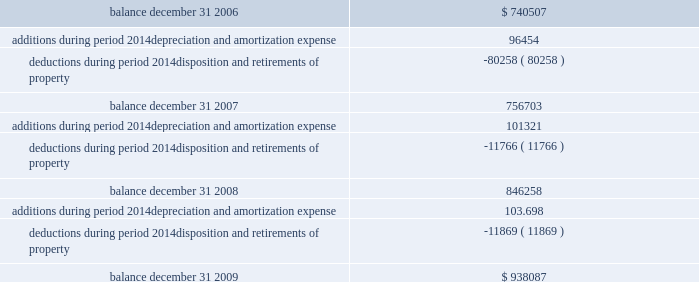Federal realty investment trust schedule iii summary of real estate and accumulated depreciation 2014continued three years ended december 31 , 2009 reconciliation of accumulated depreciation and amortization ( in thousands ) .

Considering the years 2006-2009 , what is the value of the average additions? 
Rationale: it is the sum of the additions value divide by the sum of the years .
Computations: (((96454 + 101321) + (1000 * 103.698)) / 3)
Answer: 100491.0. Federal realty investment trust schedule iii summary of real estate and accumulated depreciation 2014continued three years ended december 31 , 2009 reconciliation of accumulated depreciation and amortization ( in thousands ) .

What is the percentual decline of the deductions during 2007 and 2008? 
Rationale: it is the percentual variation of the value of the deduction , which is calculated by subtracting the initial value of the final value , then dividing by the initial value and turning it into a percentage .
Computations: ((11766 - 80258) / 80258)
Answer: -0.8534. 